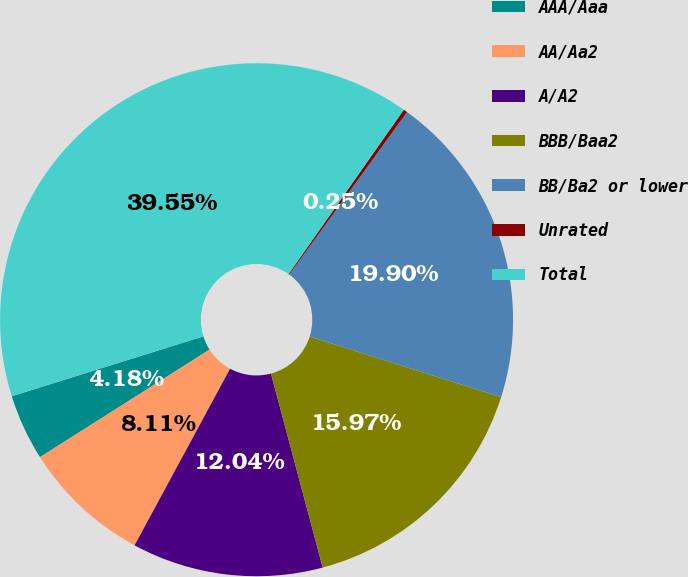Convert chart. <chart><loc_0><loc_0><loc_500><loc_500><pie_chart><fcel>AAA/Aaa<fcel>AA/Aa2<fcel>A/A2<fcel>BBB/Baa2<fcel>BB/Ba2 or lower<fcel>Unrated<fcel>Total<nl><fcel>4.18%<fcel>8.11%<fcel>12.04%<fcel>15.97%<fcel>19.9%<fcel>0.25%<fcel>39.55%<nl></chart> 